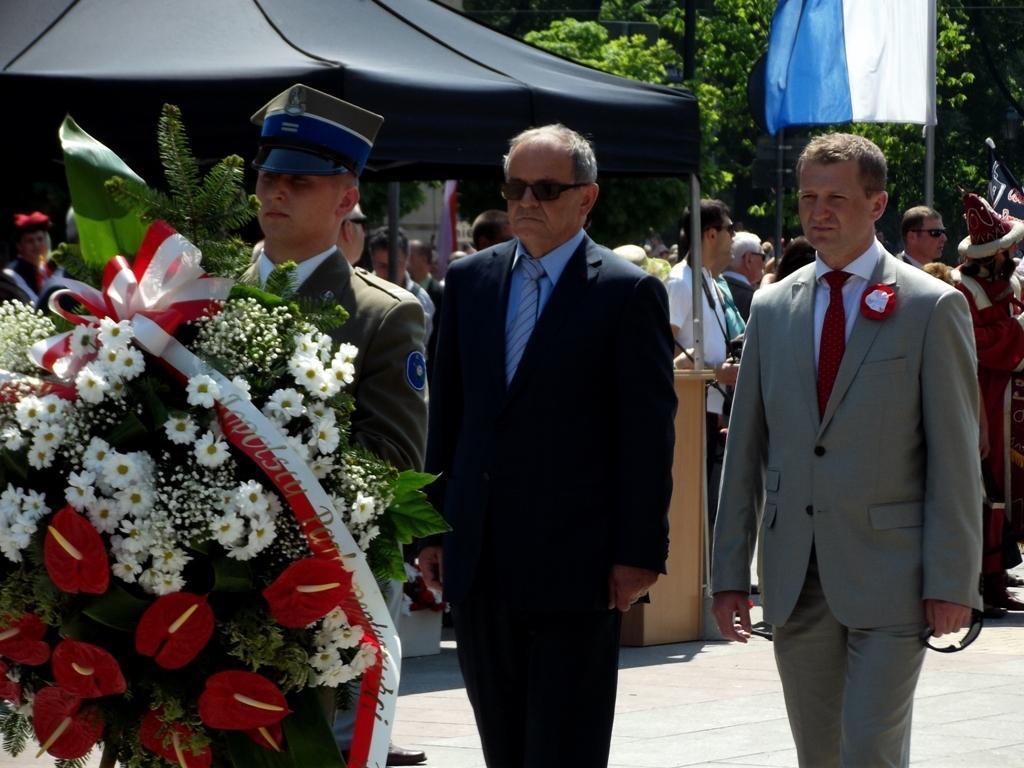Can you describe this image briefly? On the left side a man is holding the bouquet of flowers, in the middle a man is standing. He wore black color coat,trouser, behind him there is another man standing, there is a tent in this image with black color. 